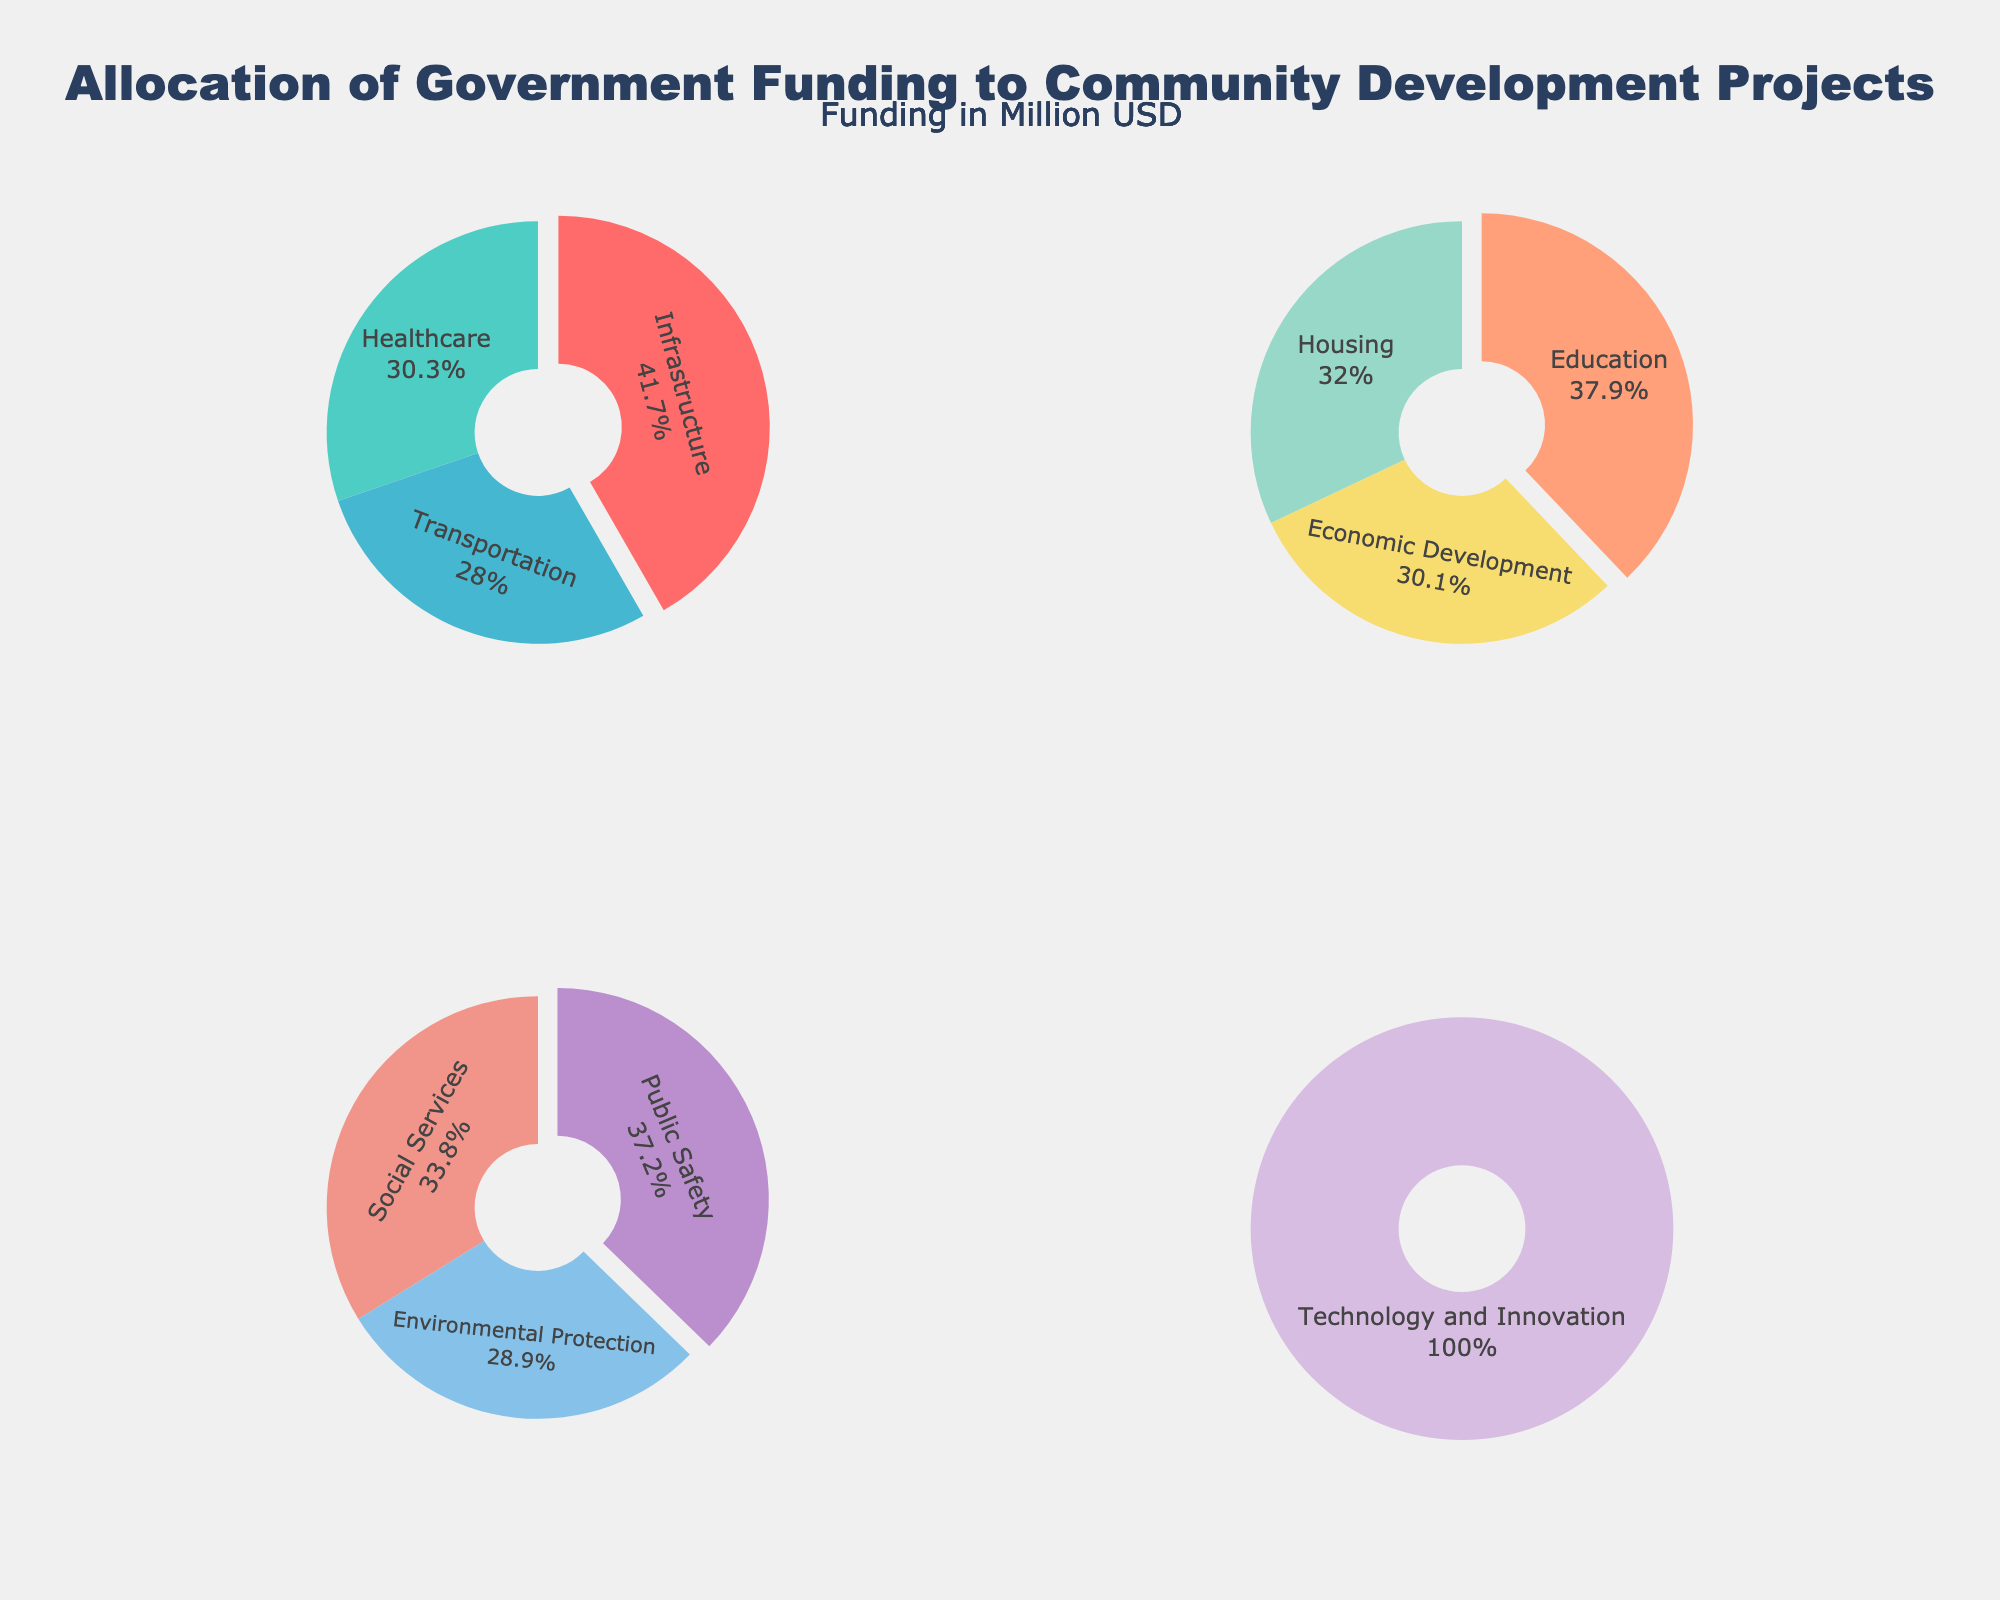What are the top three projects based on funding? The top three projects based on funding can be directly inferred from the first subplot titled "Top 3 Projects."
Answer: Infrastructure, Healthcare, Education What percentage of the total funding is allocated to the Transportation project? This requires finding the Transportation project in the third subplot and observing the percentage slice it occupies.
Answer: Approximately 9% How does the funding for Technology and Innovation compare to Housing? We need to observe the position and size of the slices for both Technology and Innovation (last subplot) and Housing (third subplot).
Answer: Technology and Innovation receives less funding than Housing What is the combined funding allocated to Social Services and Housing? First, locate Social Services in the third subplot and Housing in the third subplot, then add their funding amounts: 17.9 + 24.1 (Million USD).
Answer: 42 Million USD Which project receives the least amount of funding and how much is it? The least funded project will be in the last subplot titled "Bottom Project."
Answer: Technology and Innovation, 13.5 Million USD What is the difference in funding between Healthcare and Public Safety? Locate Healthcare in the top subplot and Public Safety in the second subplot, then subtract their funding amounts: 32.8 - 19.7 (Million USD).
Answer: 13.1 Million USD How many projects receive more than 20 Million USD in funding each? We need to count the number of projects in the first and second subplots whose funding exceeds 20 Million USD.
Answer: 5 Which group of projects receives the highest combined funding: Top 3, Next 3, or Third 3? Sum the funding amounts in each group and compare: Top 3 (45.2 + 32.8 + 28.5), Next 3 (30.4 + 24.1 + 22.6), Third 3 (19.7 + 17.9 + 15.3).
Answer: Top 3 What is the average funding for the bottom most funded project? Since there is only one project in the bottom group, the average funding is the funding of that single project.
Answer: 13.5 Million USD Which two projects have the closest funding amounts? By visually comparing the sizes of the slices in each subplot, Housing and Economic Development appear similar. Housing: 24.1 Million USD, Economic Development: 22.6 Million USD.
Answer: Housing and Economic Development 